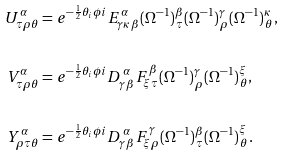<formula> <loc_0><loc_0><loc_500><loc_500>U ^ { \alpha } _ { \tau \rho \theta } & = e ^ { - \frac { 1 } { 2 } \theta _ { i } \phi { i } } E _ { \gamma \kappa \, \beta } ^ { \, \alpha } ( \Omega ^ { - 1 } ) ^ { \beta } _ { \, \tau } ( \Omega ^ { - 1 } ) ^ { \gamma } _ { \, \rho } ( \Omega ^ { - 1 } ) ^ { \kappa } _ { \, \theta } , \\ \\ V ^ { \alpha } _ { \tau \rho \theta } & = e ^ { - \frac { 1 } { 2 } \theta _ { i } \phi { i } } D _ { \gamma \, \beta } ^ { \, \alpha } F _ { \xi \, \tau } ^ { \, \beta } ( \Omega ^ { - 1 } ) ^ { \gamma } _ { \, \rho } ( \Omega ^ { - 1 } ) ^ { \xi } _ { \, \theta } , \\ \\ Y ^ { \alpha } _ { \rho \tau \theta } & = e ^ { - \frac { 1 } { 2 } \theta _ { i } \phi { i } } D _ { \gamma \, \beta } ^ { \, \alpha } F _ { \xi \, \rho } ^ { \, \gamma } ( \Omega ^ { - 1 } ) ^ { \beta } _ { \, \tau } ( \Omega ^ { - 1 } ) ^ { \xi } _ { \, \theta } .</formula> 